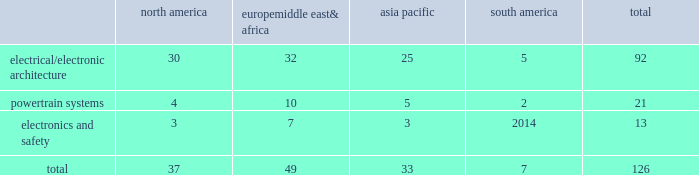Table of contents item 1b .
Unresolved staff comments we have no unresolved sec staff comments to report .
Item 2 .
Properties as of december 31 , 2015 , we owned or leased 126 major manufacturing sites and 14 major technical centers .
A manufacturing site may include multiple plants and may be wholly or partially owned or leased .
We also have many smaller manufacturing sites , sales offices , warehouses , engineering centers , joint ventures and other investments strategically located throughout the world .
We have a presence in 44 countries .
The table shows the regional distribution of our major manufacturing sites by the operating segment that uses such facilities : north america europe , middle east & africa asia pacific south america total .
In addition to these manufacturing sites , we had 14 major technical centers : four in north america ; five in europe , middle east and africa ; four in asia pacific ; and one in south america .
Of our 126 major manufacturing sites and 14 major technical centers , which include facilities owned or leased by our consolidated subsidiaries , 77 are primarily owned and 63 are primarily leased .
We frequently review our real estate portfolio and develop footprint strategies to support our customers 2019 global plans , while at the same time supporting our technical needs and controlling operating expenses .
We believe our evolving portfolio will meet current and anticipated future needs .
Item 3 .
Legal proceedings we are from time to time subject to various actions , claims , suits , government investigations , and other proceedings incidental to our business , including those arising out of alleged defects , breach of contracts , competition and antitrust matters , product warranties , intellectual property matters , personal injury claims and employment-related matters .
It is our opinion that the outcome of such matters will not have a material adverse impact on our consolidated financial position , results of operations , or cash flows .
With respect to warranty matters , although we cannot ensure that the future costs of warranty claims by customers will not be material , we believe our established reserves are adequate to cover potential warranty settlements .
However , the final amounts required to resolve these matters could differ materially from our recorded estimates .
Gm ignition switch recall in the first quarter of 2014 , gm , delphi 2019s largest customer , initiated a product recall related to ignition switches .
Delphi received requests for information from , and cooperated with , various government agencies related to this ignition switch recall .
In addition , delphi was initially named as a co-defendant along with gm ( and in certain cases other parties ) in class action and product liability lawsuits related to this matter .
As of december 31 , 2015 , delphi was not named as a defendant in any class action complaints .
Although no assurances can be made as to the ultimate outcome of these or any other future claims , delphi does not believe a loss is probable and , accordingly , no reserve has been made as of december 31 , 2015 .
Unsecured creditors litigation the fourth amended and restated limited liability partnership agreement of delphi automotive llp ( the 201cfourth llp agreement 201d ) was entered into on july 12 , 2011 by the members of delphi automotive llp in order to position the company for its initial public offering .
Under the terms of the fourth llp agreement , if cumulative distributions to the members of delphi automotive llp under certain provisions of the fourth llp agreement exceed $ 7.2 billion , delphi , as disbursing agent on behalf of dphh , is required to pay to the holders of allowed general unsecured claims against dphh $ 32.50 for every $ 67.50 in excess of $ 7.2 billion distributed to the members , up to a maximum amount of $ 300 million .
In december 2014 , a complaint was filed in the bankruptcy court alleging that the redemption by delphi automotive llp of the membership interests of gm and the pbgc , and the repurchase of shares and payment of dividends by delphi automotive plc , constituted distributions under the terms of the fourth llp agreement approximating $ 7.2 billion .
Delphi considers cumulative .
What is the percentage of electrical/electronic architecture sites among all sites? 
Rationale: it is the number of electrical/electronic architecture sites divided by all sites , then turned into a percentage .
Computations: (92 / 126)
Answer: 0.73016. 